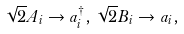<formula> <loc_0><loc_0><loc_500><loc_500>\sqrt { 2 } A _ { i } \rightarrow a ^ { \dagger } _ { i } , \, \sqrt { 2 } B _ { i } \rightarrow a _ { i } ,</formula> 